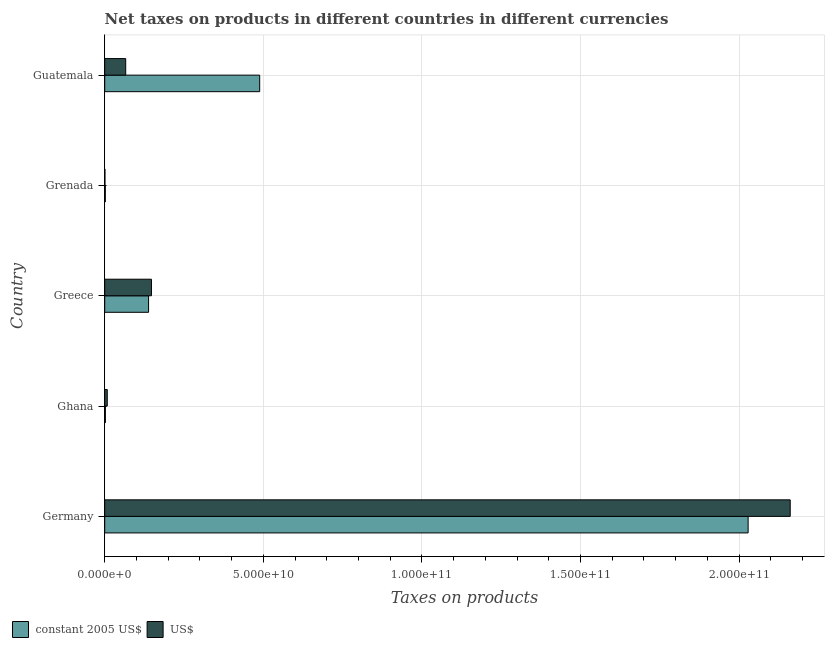How many different coloured bars are there?
Provide a short and direct response. 2. How many groups of bars are there?
Your response must be concise. 5. Are the number of bars per tick equal to the number of legend labels?
Your answer should be compact. Yes. How many bars are there on the 1st tick from the top?
Provide a succinct answer. 2. What is the label of the 4th group of bars from the top?
Your answer should be compact. Ghana. In how many cases, is the number of bars for a given country not equal to the number of legend labels?
Make the answer very short. 0. What is the net taxes in us$ in Ghana?
Ensure brevity in your answer.  8.03e+08. Across all countries, what is the maximum net taxes in us$?
Offer a terse response. 2.16e+11. Across all countries, what is the minimum net taxes in us$?
Make the answer very short. 6.90e+07. In which country was the net taxes in constant 2005 us$ maximum?
Your answer should be very brief. Germany. In which country was the net taxes in us$ minimum?
Ensure brevity in your answer.  Grenada. What is the total net taxes in constant 2005 us$ in the graph?
Make the answer very short. 2.66e+11. What is the difference between the net taxes in constant 2005 us$ in Ghana and that in Greece?
Offer a very short reply. -1.36e+1. What is the difference between the net taxes in constant 2005 us$ in Guatemala and the net taxes in us$ in Grenada?
Your answer should be compact. 4.88e+1. What is the average net taxes in us$ per country?
Ensure brevity in your answer.  4.77e+1. What is the difference between the net taxes in constant 2005 us$ and net taxes in us$ in Grenada?
Ensure brevity in your answer.  1.17e+08. In how many countries, is the net taxes in us$ greater than 60000000000 units?
Give a very brief answer. 1. What is the ratio of the net taxes in us$ in Ghana to that in Guatemala?
Offer a very short reply. 0.12. Is the difference between the net taxes in us$ in Germany and Greece greater than the difference between the net taxes in constant 2005 us$ in Germany and Greece?
Your response must be concise. Yes. What is the difference between the highest and the second highest net taxes in constant 2005 us$?
Provide a succinct answer. 1.54e+11. What is the difference between the highest and the lowest net taxes in us$?
Provide a succinct answer. 2.16e+11. Is the sum of the net taxes in constant 2005 us$ in Germany and Grenada greater than the maximum net taxes in us$ across all countries?
Ensure brevity in your answer.  No. What does the 1st bar from the top in Ghana represents?
Your response must be concise. US$. What does the 1st bar from the bottom in Guatemala represents?
Offer a terse response. Constant 2005 us$. How many bars are there?
Your answer should be very brief. 10. What is the difference between two consecutive major ticks on the X-axis?
Keep it short and to the point. 5.00e+1. Does the graph contain grids?
Make the answer very short. Yes. Where does the legend appear in the graph?
Provide a short and direct response. Bottom left. How many legend labels are there?
Provide a succinct answer. 2. What is the title of the graph?
Your answer should be compact. Net taxes on products in different countries in different currencies. Does "Urban agglomerations" appear as one of the legend labels in the graph?
Make the answer very short. No. What is the label or title of the X-axis?
Your response must be concise. Taxes on products. What is the label or title of the Y-axis?
Your answer should be compact. Country. What is the Taxes on products of constant 2005 US$ in Germany?
Your answer should be compact. 2.03e+11. What is the Taxes on products of US$ in Germany?
Offer a very short reply. 2.16e+11. What is the Taxes on products of constant 2005 US$ in Ghana?
Provide a short and direct response. 2.14e+08. What is the Taxes on products of US$ in Ghana?
Offer a very short reply. 8.03e+08. What is the Taxes on products of constant 2005 US$ in Greece?
Ensure brevity in your answer.  1.38e+1. What is the Taxes on products in US$ in Greece?
Provide a short and direct response. 1.47e+1. What is the Taxes on products in constant 2005 US$ in Grenada?
Offer a terse response. 1.86e+08. What is the Taxes on products of US$ in Grenada?
Your response must be concise. 6.90e+07. What is the Taxes on products of constant 2005 US$ in Guatemala?
Your response must be concise. 4.89e+1. What is the Taxes on products of US$ in Guatemala?
Your answer should be very brief. 6.61e+09. Across all countries, what is the maximum Taxes on products in constant 2005 US$?
Give a very brief answer. 2.03e+11. Across all countries, what is the maximum Taxes on products in US$?
Offer a very short reply. 2.16e+11. Across all countries, what is the minimum Taxes on products of constant 2005 US$?
Provide a short and direct response. 1.86e+08. Across all countries, what is the minimum Taxes on products in US$?
Provide a short and direct response. 6.90e+07. What is the total Taxes on products of constant 2005 US$ in the graph?
Offer a terse response. 2.66e+11. What is the total Taxes on products in US$ in the graph?
Your response must be concise. 2.38e+11. What is the difference between the Taxes on products in constant 2005 US$ in Germany and that in Ghana?
Make the answer very short. 2.03e+11. What is the difference between the Taxes on products of US$ in Germany and that in Ghana?
Make the answer very short. 2.15e+11. What is the difference between the Taxes on products in constant 2005 US$ in Germany and that in Greece?
Keep it short and to the point. 1.89e+11. What is the difference between the Taxes on products of US$ in Germany and that in Greece?
Give a very brief answer. 2.01e+11. What is the difference between the Taxes on products in constant 2005 US$ in Germany and that in Grenada?
Offer a terse response. 2.03e+11. What is the difference between the Taxes on products of US$ in Germany and that in Grenada?
Keep it short and to the point. 2.16e+11. What is the difference between the Taxes on products in constant 2005 US$ in Germany and that in Guatemala?
Make the answer very short. 1.54e+11. What is the difference between the Taxes on products of US$ in Germany and that in Guatemala?
Offer a very short reply. 2.09e+11. What is the difference between the Taxes on products of constant 2005 US$ in Ghana and that in Greece?
Your response must be concise. -1.36e+1. What is the difference between the Taxes on products of US$ in Ghana and that in Greece?
Make the answer very short. -1.39e+1. What is the difference between the Taxes on products of constant 2005 US$ in Ghana and that in Grenada?
Make the answer very short. 2.77e+07. What is the difference between the Taxes on products in US$ in Ghana and that in Grenada?
Make the answer very short. 7.34e+08. What is the difference between the Taxes on products of constant 2005 US$ in Ghana and that in Guatemala?
Offer a very short reply. -4.86e+1. What is the difference between the Taxes on products of US$ in Ghana and that in Guatemala?
Your answer should be very brief. -5.81e+09. What is the difference between the Taxes on products in constant 2005 US$ in Greece and that in Grenada?
Offer a terse response. 1.36e+1. What is the difference between the Taxes on products of US$ in Greece and that in Grenada?
Make the answer very short. 1.47e+1. What is the difference between the Taxes on products of constant 2005 US$ in Greece and that in Guatemala?
Offer a terse response. -3.50e+1. What is the difference between the Taxes on products of US$ in Greece and that in Guatemala?
Give a very brief answer. 8.12e+09. What is the difference between the Taxes on products of constant 2005 US$ in Grenada and that in Guatemala?
Offer a terse response. -4.87e+1. What is the difference between the Taxes on products of US$ in Grenada and that in Guatemala?
Make the answer very short. -6.55e+09. What is the difference between the Taxes on products in constant 2005 US$ in Germany and the Taxes on products in US$ in Ghana?
Offer a very short reply. 2.02e+11. What is the difference between the Taxes on products of constant 2005 US$ in Germany and the Taxes on products of US$ in Greece?
Provide a short and direct response. 1.88e+11. What is the difference between the Taxes on products of constant 2005 US$ in Germany and the Taxes on products of US$ in Grenada?
Your response must be concise. 2.03e+11. What is the difference between the Taxes on products in constant 2005 US$ in Germany and the Taxes on products in US$ in Guatemala?
Your response must be concise. 1.96e+11. What is the difference between the Taxes on products of constant 2005 US$ in Ghana and the Taxes on products of US$ in Greece?
Your answer should be very brief. -1.45e+1. What is the difference between the Taxes on products in constant 2005 US$ in Ghana and the Taxes on products in US$ in Grenada?
Ensure brevity in your answer.  1.45e+08. What is the difference between the Taxes on products in constant 2005 US$ in Ghana and the Taxes on products in US$ in Guatemala?
Provide a short and direct response. -6.40e+09. What is the difference between the Taxes on products in constant 2005 US$ in Greece and the Taxes on products in US$ in Grenada?
Your response must be concise. 1.38e+1. What is the difference between the Taxes on products of constant 2005 US$ in Greece and the Taxes on products of US$ in Guatemala?
Ensure brevity in your answer.  7.21e+09. What is the difference between the Taxes on products of constant 2005 US$ in Grenada and the Taxes on products of US$ in Guatemala?
Give a very brief answer. -6.43e+09. What is the average Taxes on products in constant 2005 US$ per country?
Ensure brevity in your answer.  5.32e+1. What is the average Taxes on products of US$ per country?
Your response must be concise. 4.77e+1. What is the difference between the Taxes on products in constant 2005 US$ and Taxes on products in US$ in Germany?
Keep it short and to the point. -1.33e+1. What is the difference between the Taxes on products in constant 2005 US$ and Taxes on products in US$ in Ghana?
Your answer should be very brief. -5.89e+08. What is the difference between the Taxes on products in constant 2005 US$ and Taxes on products in US$ in Greece?
Make the answer very short. -9.05e+08. What is the difference between the Taxes on products of constant 2005 US$ and Taxes on products of US$ in Grenada?
Make the answer very short. 1.17e+08. What is the difference between the Taxes on products in constant 2005 US$ and Taxes on products in US$ in Guatemala?
Your answer should be compact. 4.22e+1. What is the ratio of the Taxes on products in constant 2005 US$ in Germany to that in Ghana?
Give a very brief answer. 947.97. What is the ratio of the Taxes on products in US$ in Germany to that in Ghana?
Keep it short and to the point. 269.26. What is the ratio of the Taxes on products in constant 2005 US$ in Germany to that in Greece?
Your answer should be compact. 14.67. What is the ratio of the Taxes on products in US$ in Germany to that in Greece?
Ensure brevity in your answer.  14.67. What is the ratio of the Taxes on products in constant 2005 US$ in Germany to that in Grenada?
Offer a very short reply. 1088.74. What is the ratio of the Taxes on products in US$ in Germany to that in Grenada?
Provide a succinct answer. 3131.89. What is the ratio of the Taxes on products in constant 2005 US$ in Germany to that in Guatemala?
Your response must be concise. 4.15. What is the ratio of the Taxes on products in US$ in Germany to that in Guatemala?
Offer a terse response. 32.67. What is the ratio of the Taxes on products of constant 2005 US$ in Ghana to that in Greece?
Offer a very short reply. 0.02. What is the ratio of the Taxes on products in US$ in Ghana to that in Greece?
Keep it short and to the point. 0.05. What is the ratio of the Taxes on products in constant 2005 US$ in Ghana to that in Grenada?
Make the answer very short. 1.15. What is the ratio of the Taxes on products of US$ in Ghana to that in Grenada?
Offer a very short reply. 11.63. What is the ratio of the Taxes on products in constant 2005 US$ in Ghana to that in Guatemala?
Provide a succinct answer. 0. What is the ratio of the Taxes on products of US$ in Ghana to that in Guatemala?
Offer a terse response. 0.12. What is the ratio of the Taxes on products of constant 2005 US$ in Greece to that in Grenada?
Ensure brevity in your answer.  74.22. What is the ratio of the Taxes on products in US$ in Greece to that in Grenada?
Your answer should be compact. 213.5. What is the ratio of the Taxes on products in constant 2005 US$ in Greece to that in Guatemala?
Your response must be concise. 0.28. What is the ratio of the Taxes on products of US$ in Greece to that in Guatemala?
Keep it short and to the point. 2.23. What is the ratio of the Taxes on products of constant 2005 US$ in Grenada to that in Guatemala?
Offer a terse response. 0. What is the ratio of the Taxes on products in US$ in Grenada to that in Guatemala?
Provide a succinct answer. 0.01. What is the difference between the highest and the second highest Taxes on products in constant 2005 US$?
Provide a short and direct response. 1.54e+11. What is the difference between the highest and the second highest Taxes on products in US$?
Offer a very short reply. 2.01e+11. What is the difference between the highest and the lowest Taxes on products in constant 2005 US$?
Your response must be concise. 2.03e+11. What is the difference between the highest and the lowest Taxes on products of US$?
Provide a short and direct response. 2.16e+11. 